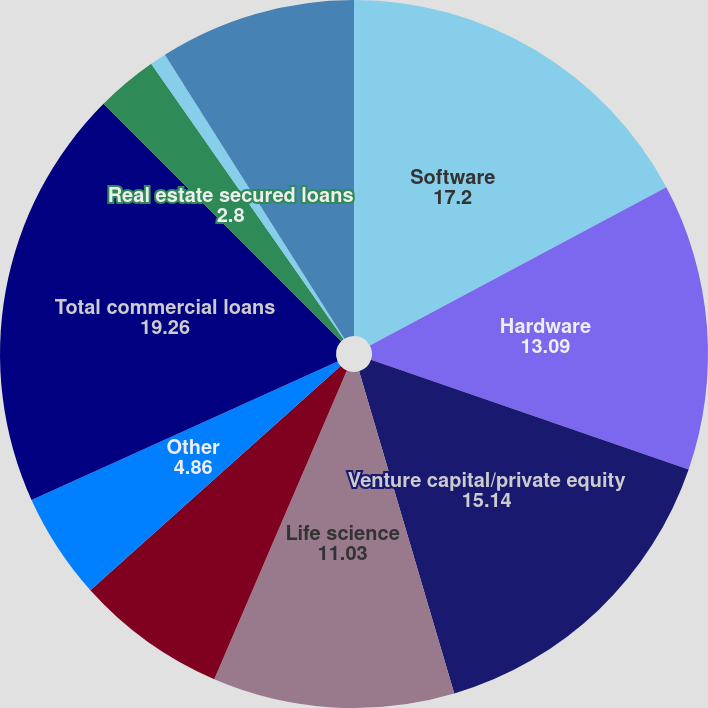<chart> <loc_0><loc_0><loc_500><loc_500><pie_chart><fcel>Software<fcel>Hardware<fcel>Venture capital/private equity<fcel>Life science<fcel>Premium wine<fcel>Other<fcel>Total commercial loans<fcel>Real estate secured loans<fcel>Other consumer loans<fcel>Total consumer loans<nl><fcel>17.2%<fcel>13.09%<fcel>15.14%<fcel>11.03%<fcel>6.91%<fcel>4.86%<fcel>19.26%<fcel>2.8%<fcel>0.74%<fcel>8.97%<nl></chart> 